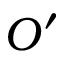Convert formula to latex. <formula><loc_0><loc_0><loc_500><loc_500>O ^ { \prime }</formula> 